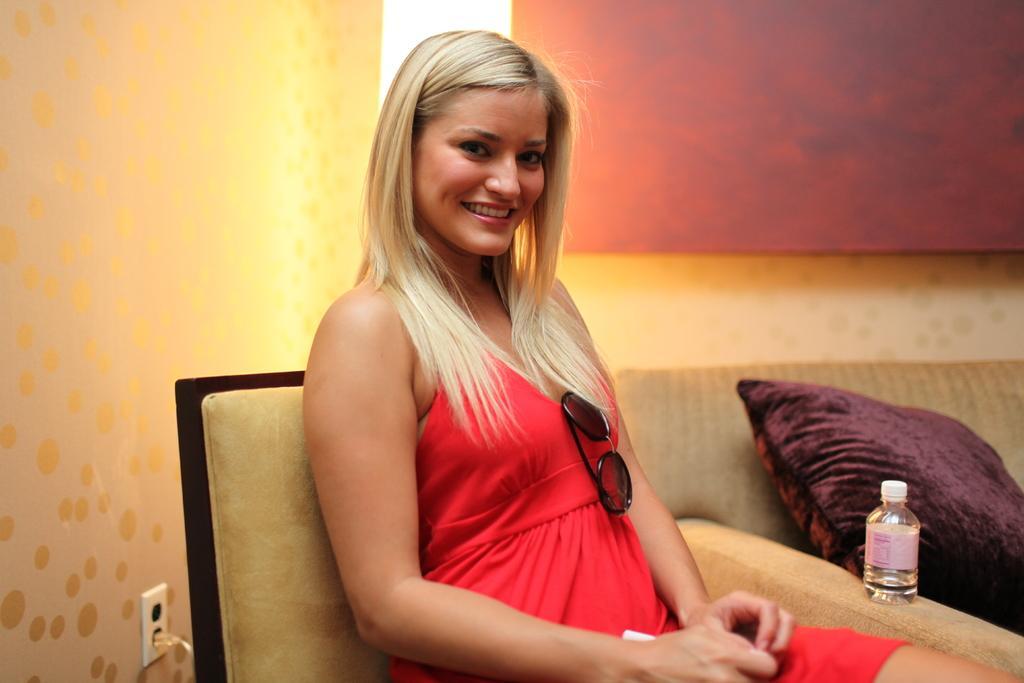In one or two sentences, can you explain what this image depicts? In this picture we can see a woman sitting on a chair and smiling and beside her we can see a sofa with a pillow on it and in the background we can see the wall. 